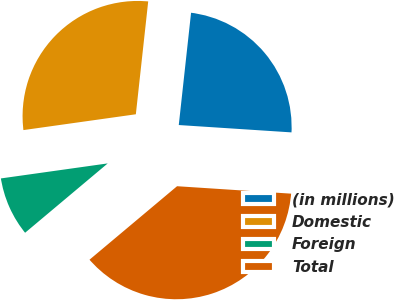Convert chart. <chart><loc_0><loc_0><loc_500><loc_500><pie_chart><fcel>(in millions)<fcel>Domestic<fcel>Foreign<fcel>Total<nl><fcel>24.3%<fcel>28.96%<fcel>8.89%<fcel>37.85%<nl></chart> 